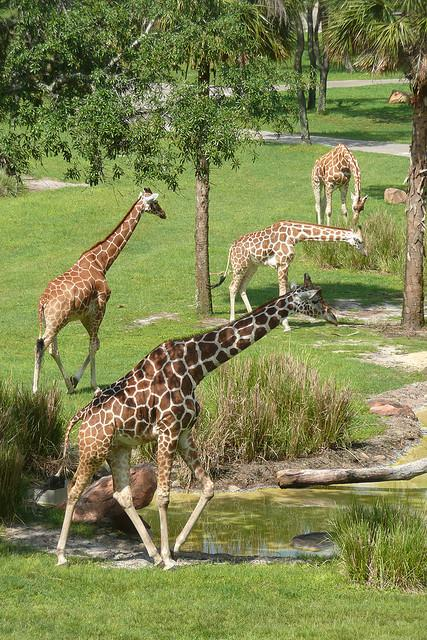What does the animal in the foreground have? Please explain your reasoning. spots. The animal has spots. 